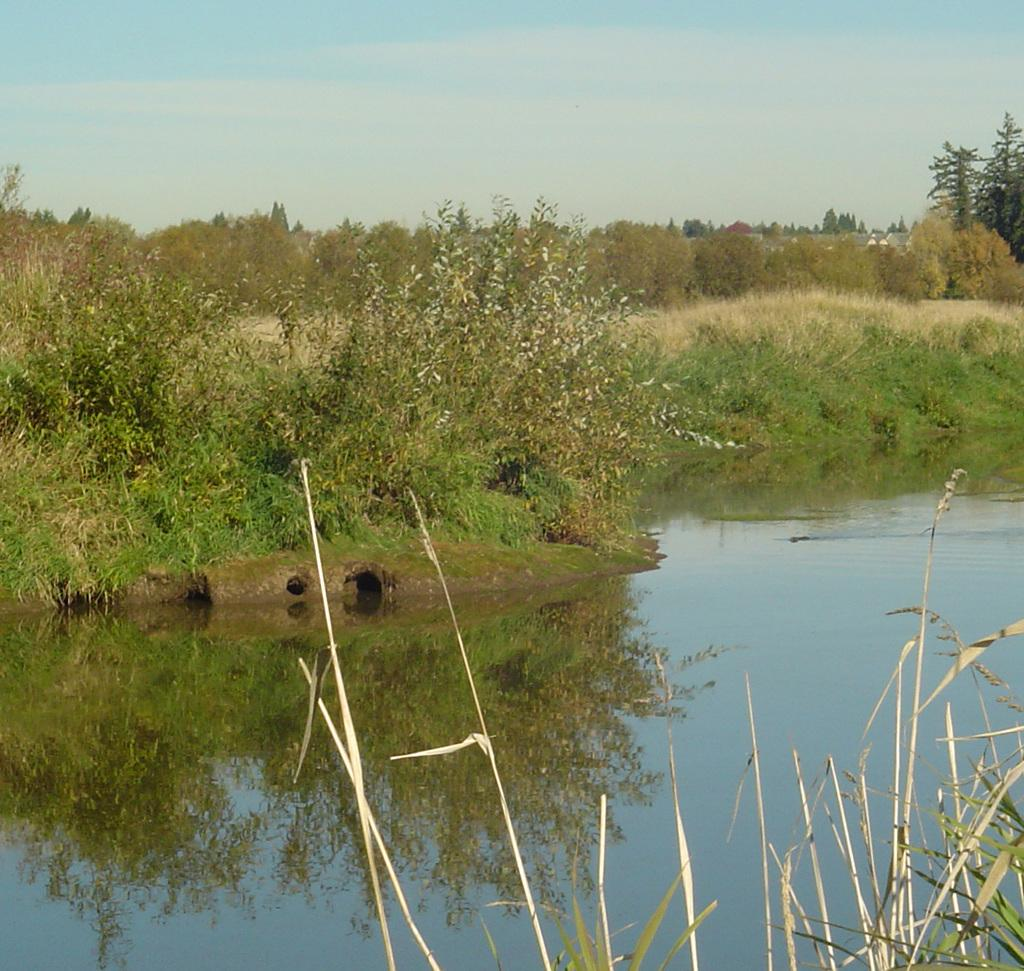What is located at the bottom of the image? There is a small pond at the bottom of the image. What can be seen in the background of the image? There are plants and grass in the background of the image. What is visible at the top of the image? The sky is visible at the top of the image. Where is the sack of potatoes located in the image? There is no sack of potatoes present in the image. What type of army is depicted in the image? There is no army present in the image. 